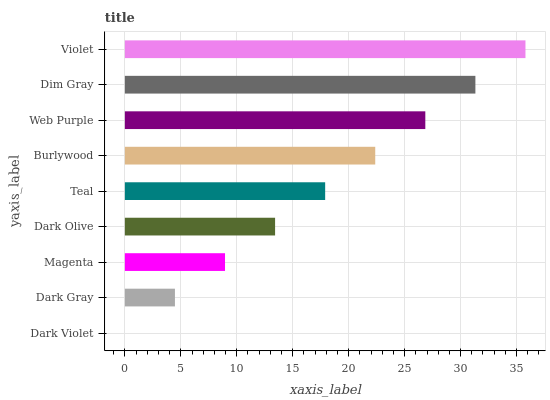Is Dark Violet the minimum?
Answer yes or no. Yes. Is Violet the maximum?
Answer yes or no. Yes. Is Dark Gray the minimum?
Answer yes or no. No. Is Dark Gray the maximum?
Answer yes or no. No. Is Dark Gray greater than Dark Violet?
Answer yes or no. Yes. Is Dark Violet less than Dark Gray?
Answer yes or no. Yes. Is Dark Violet greater than Dark Gray?
Answer yes or no. No. Is Dark Gray less than Dark Violet?
Answer yes or no. No. Is Teal the high median?
Answer yes or no. Yes. Is Teal the low median?
Answer yes or no. Yes. Is Web Purple the high median?
Answer yes or no. No. Is Dark Violet the low median?
Answer yes or no. No. 